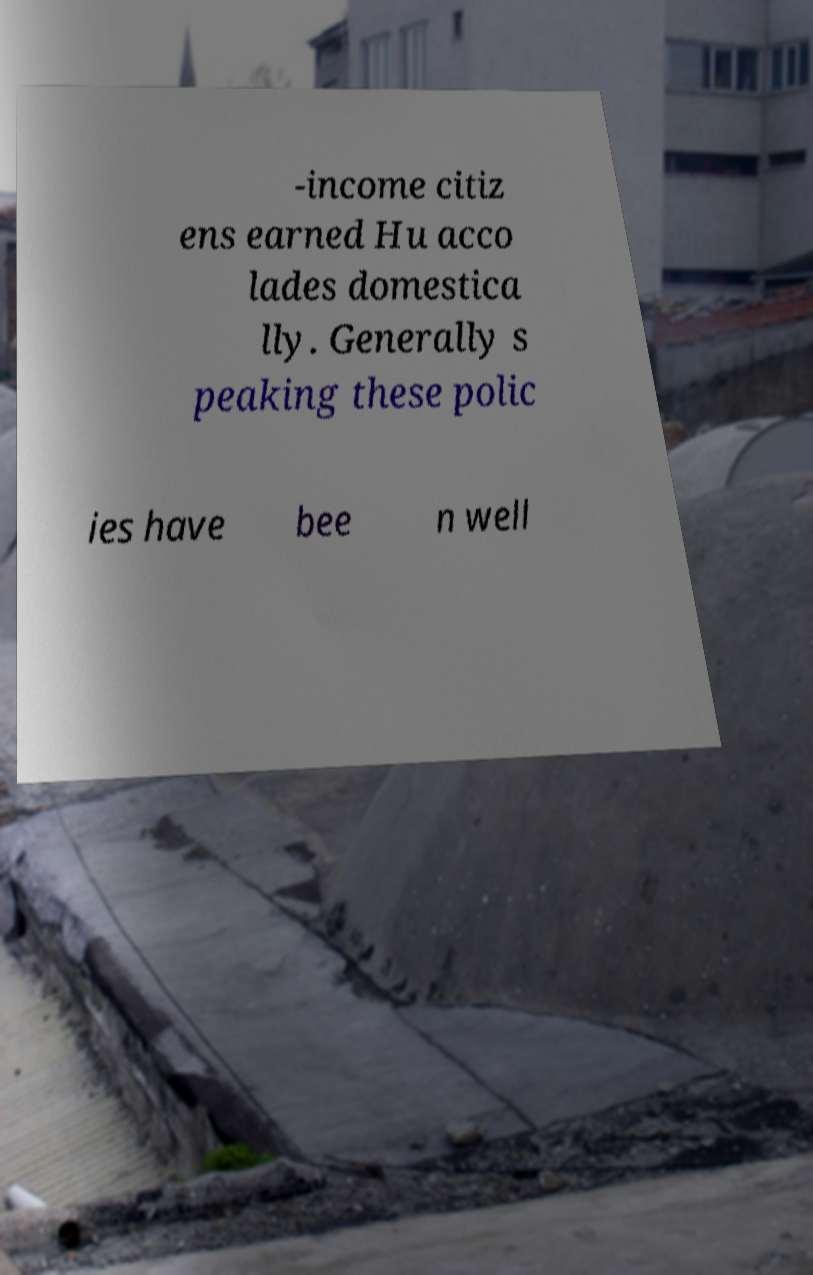For documentation purposes, I need the text within this image transcribed. Could you provide that? -income citiz ens earned Hu acco lades domestica lly. Generally s peaking these polic ies have bee n well 